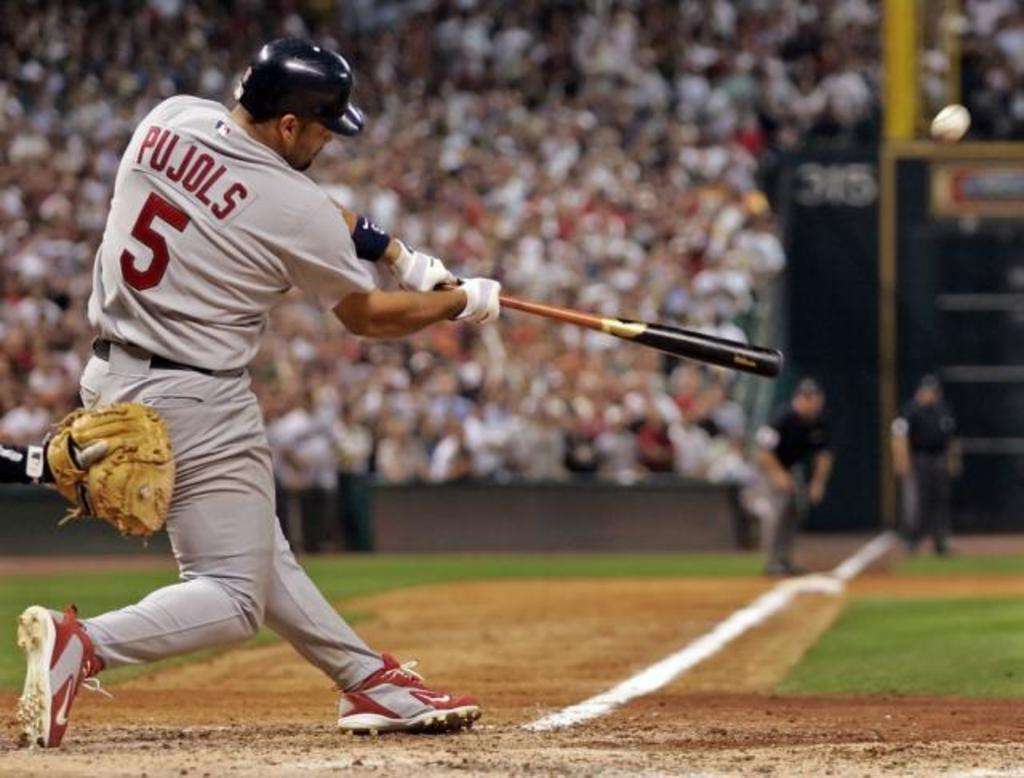<image>
Share a concise interpretation of the image provided. A baseball player called Pujols and who is number 5 swings his bat in front of a huge crowd 